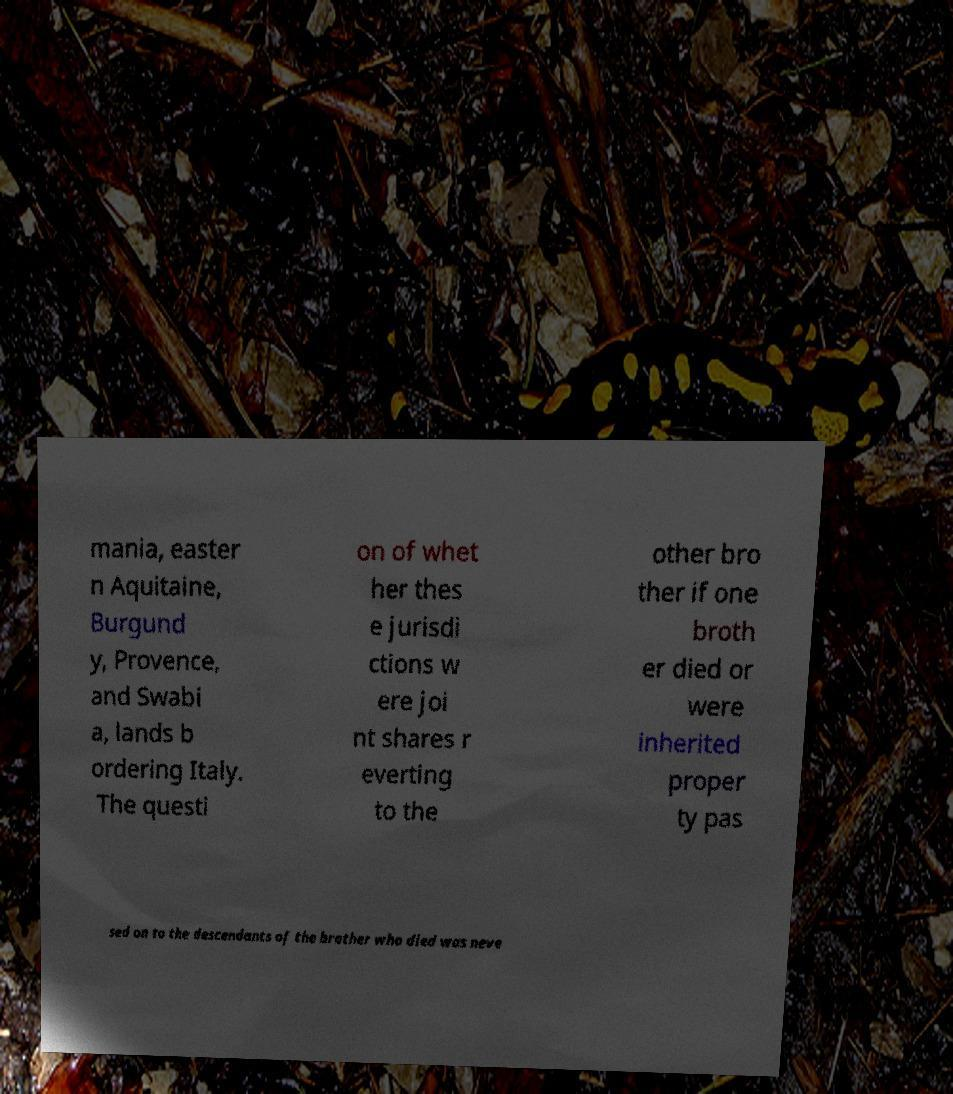What messages or text are displayed in this image? I need them in a readable, typed format. mania, easter n Aquitaine, Burgund y, Provence, and Swabi a, lands b ordering Italy. The questi on of whet her thes e jurisdi ctions w ere joi nt shares r everting to the other bro ther if one broth er died or were inherited proper ty pas sed on to the descendants of the brother who died was neve 